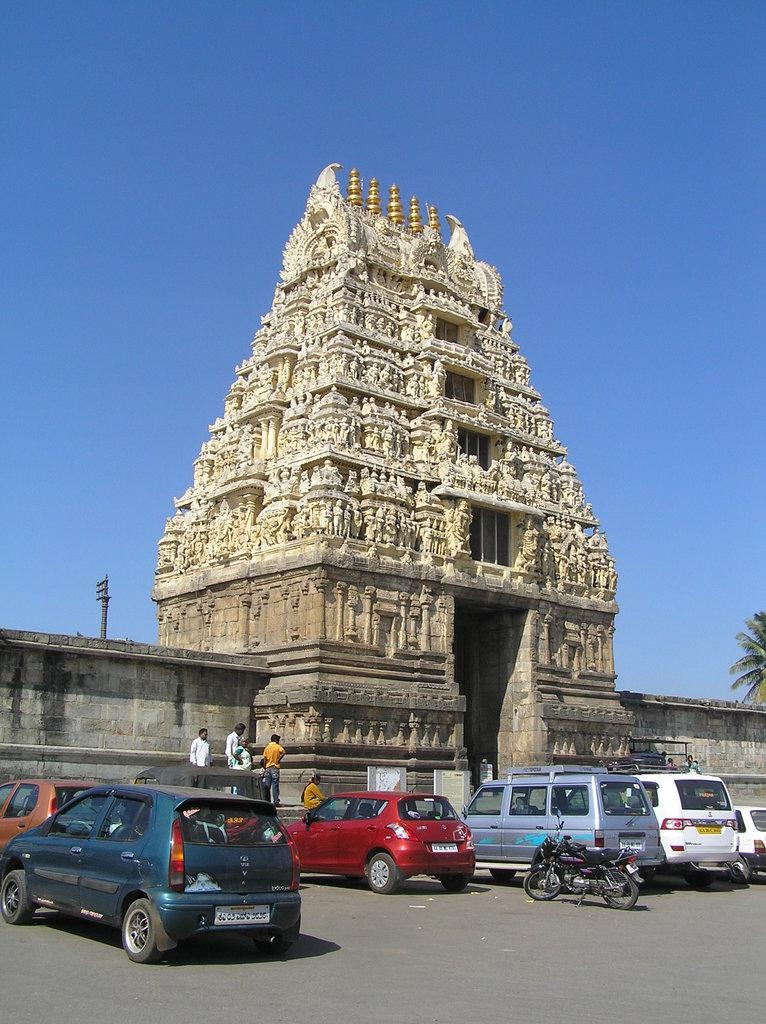What types of vehicles can be seen on the road in the image? There are vehicles on the road in the image. What specific type of vehicle is present on the road? There is a bike on the road in the image. Can you describe the people in the image? There are people in the image. What structures are visible in the image? Walls, a pole, and a tree are visible in the image. What type of architecture can be seen in the image? The architecture of a temple is visible in the image. What type of experience does the mom have with the alarm in the image? There is no mention of a mom or an alarm in the image; the focus is on vehicles, a bike, people, walls, a pole, a tree, and the architecture of a temple. 